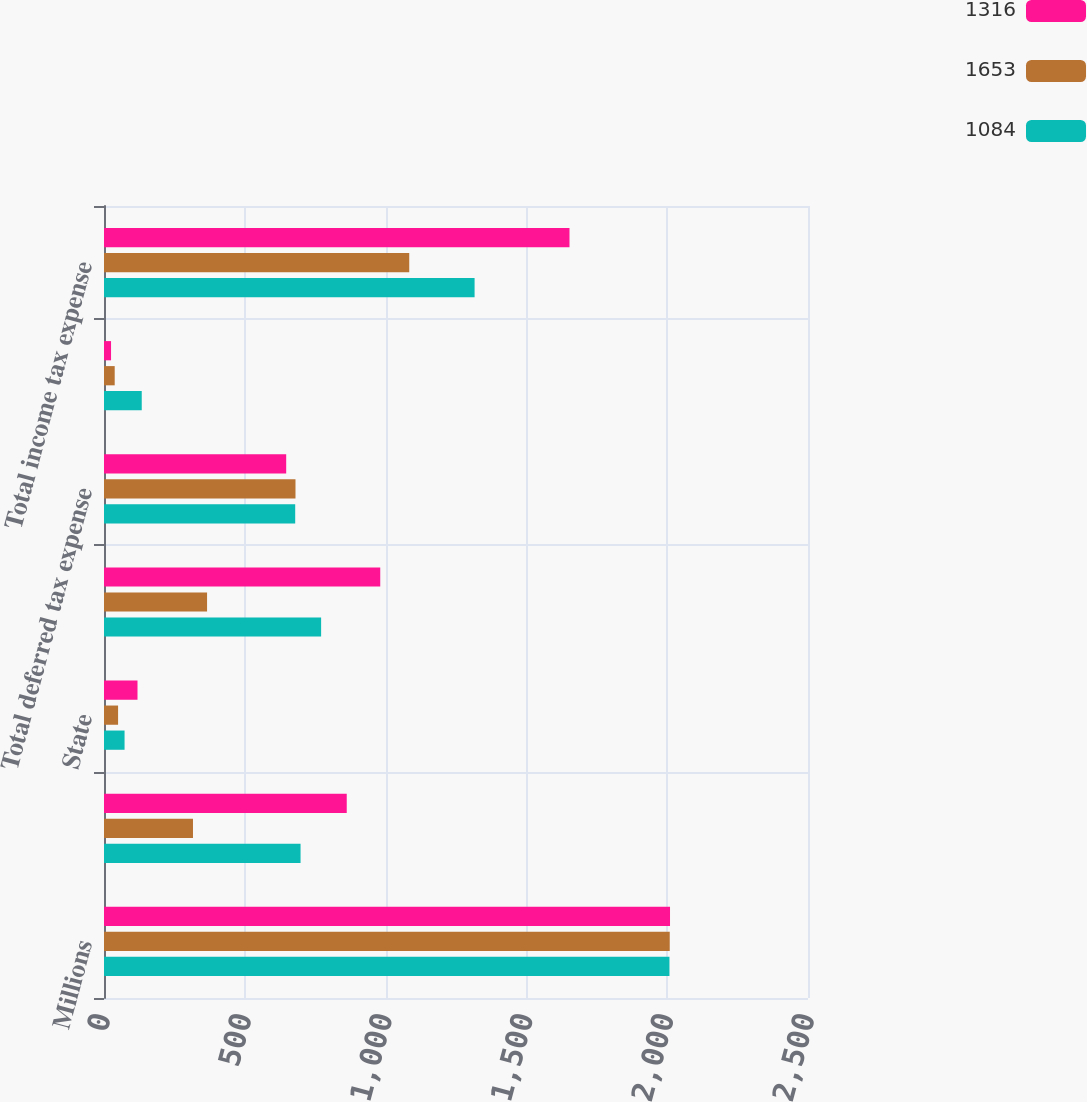Convert chart to OTSL. <chart><loc_0><loc_0><loc_500><loc_500><stacked_bar_chart><ecel><fcel>Millions<fcel>Federal<fcel>State<fcel>Total current tax expense<fcel>Total deferred tax expense<fcel>Total unrecognized tax<fcel>Total income tax expense<nl><fcel>1316<fcel>2010<fcel>862<fcel>119<fcel>981<fcel>647<fcel>25<fcel>1653<nl><fcel>1653<fcel>2009<fcel>316<fcel>50<fcel>366<fcel>680<fcel>38<fcel>1084<nl><fcel>1084<fcel>2008<fcel>698<fcel>73<fcel>771<fcel>679<fcel>134<fcel>1316<nl></chart> 